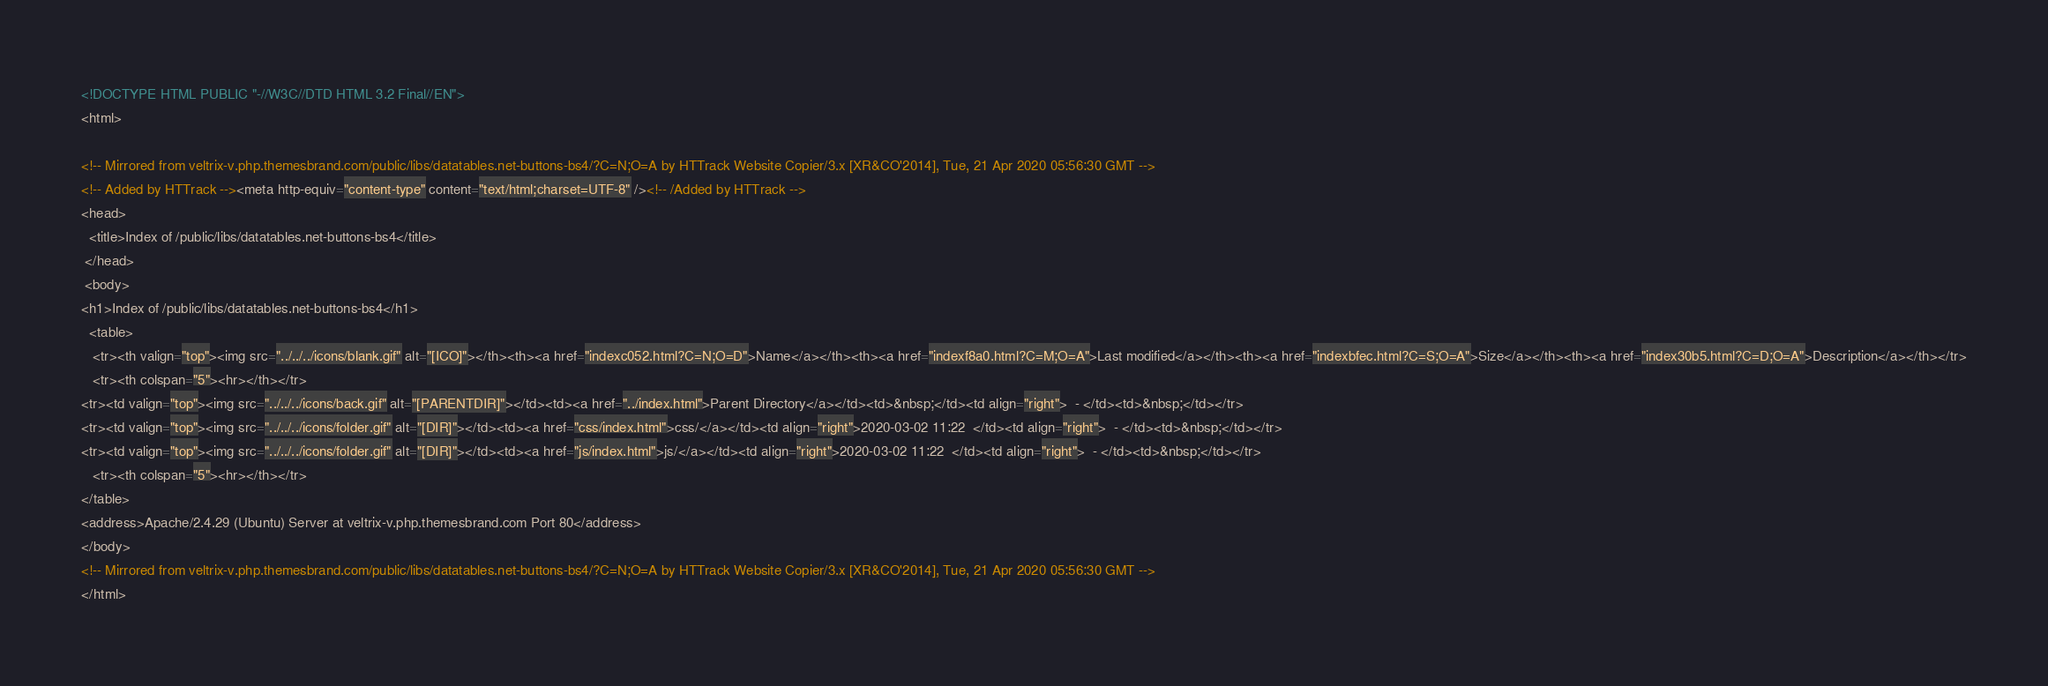<code> <loc_0><loc_0><loc_500><loc_500><_HTML_><!DOCTYPE HTML PUBLIC "-//W3C//DTD HTML 3.2 Final//EN">
<html>
 
<!-- Mirrored from veltrix-v.php.themesbrand.com/public/libs/datatables.net-buttons-bs4/?C=N;O=A by HTTrack Website Copier/3.x [XR&CO'2014], Tue, 21 Apr 2020 05:56:30 GMT -->
<!-- Added by HTTrack --><meta http-equiv="content-type" content="text/html;charset=UTF-8" /><!-- /Added by HTTrack -->
<head>
  <title>Index of /public/libs/datatables.net-buttons-bs4</title>
 </head>
 <body>
<h1>Index of /public/libs/datatables.net-buttons-bs4</h1>
  <table>
   <tr><th valign="top"><img src="../../../icons/blank.gif" alt="[ICO]"></th><th><a href="indexc052.html?C=N;O=D">Name</a></th><th><a href="indexf8a0.html?C=M;O=A">Last modified</a></th><th><a href="indexbfec.html?C=S;O=A">Size</a></th><th><a href="index30b5.html?C=D;O=A">Description</a></th></tr>
   <tr><th colspan="5"><hr></th></tr>
<tr><td valign="top"><img src="../../../icons/back.gif" alt="[PARENTDIR]"></td><td><a href="../index.html">Parent Directory</a></td><td>&nbsp;</td><td align="right">  - </td><td>&nbsp;</td></tr>
<tr><td valign="top"><img src="../../../icons/folder.gif" alt="[DIR]"></td><td><a href="css/index.html">css/</a></td><td align="right">2020-03-02 11:22  </td><td align="right">  - </td><td>&nbsp;</td></tr>
<tr><td valign="top"><img src="../../../icons/folder.gif" alt="[DIR]"></td><td><a href="js/index.html">js/</a></td><td align="right">2020-03-02 11:22  </td><td align="right">  - </td><td>&nbsp;</td></tr>
   <tr><th colspan="5"><hr></th></tr>
</table>
<address>Apache/2.4.29 (Ubuntu) Server at veltrix-v.php.themesbrand.com Port 80</address>
</body>
<!-- Mirrored from veltrix-v.php.themesbrand.com/public/libs/datatables.net-buttons-bs4/?C=N;O=A by HTTrack Website Copier/3.x [XR&CO'2014], Tue, 21 Apr 2020 05:56:30 GMT -->
</html>
</code> 